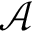Convert formula to latex. <formula><loc_0><loc_0><loc_500><loc_500>\mathcal { A }</formula> 